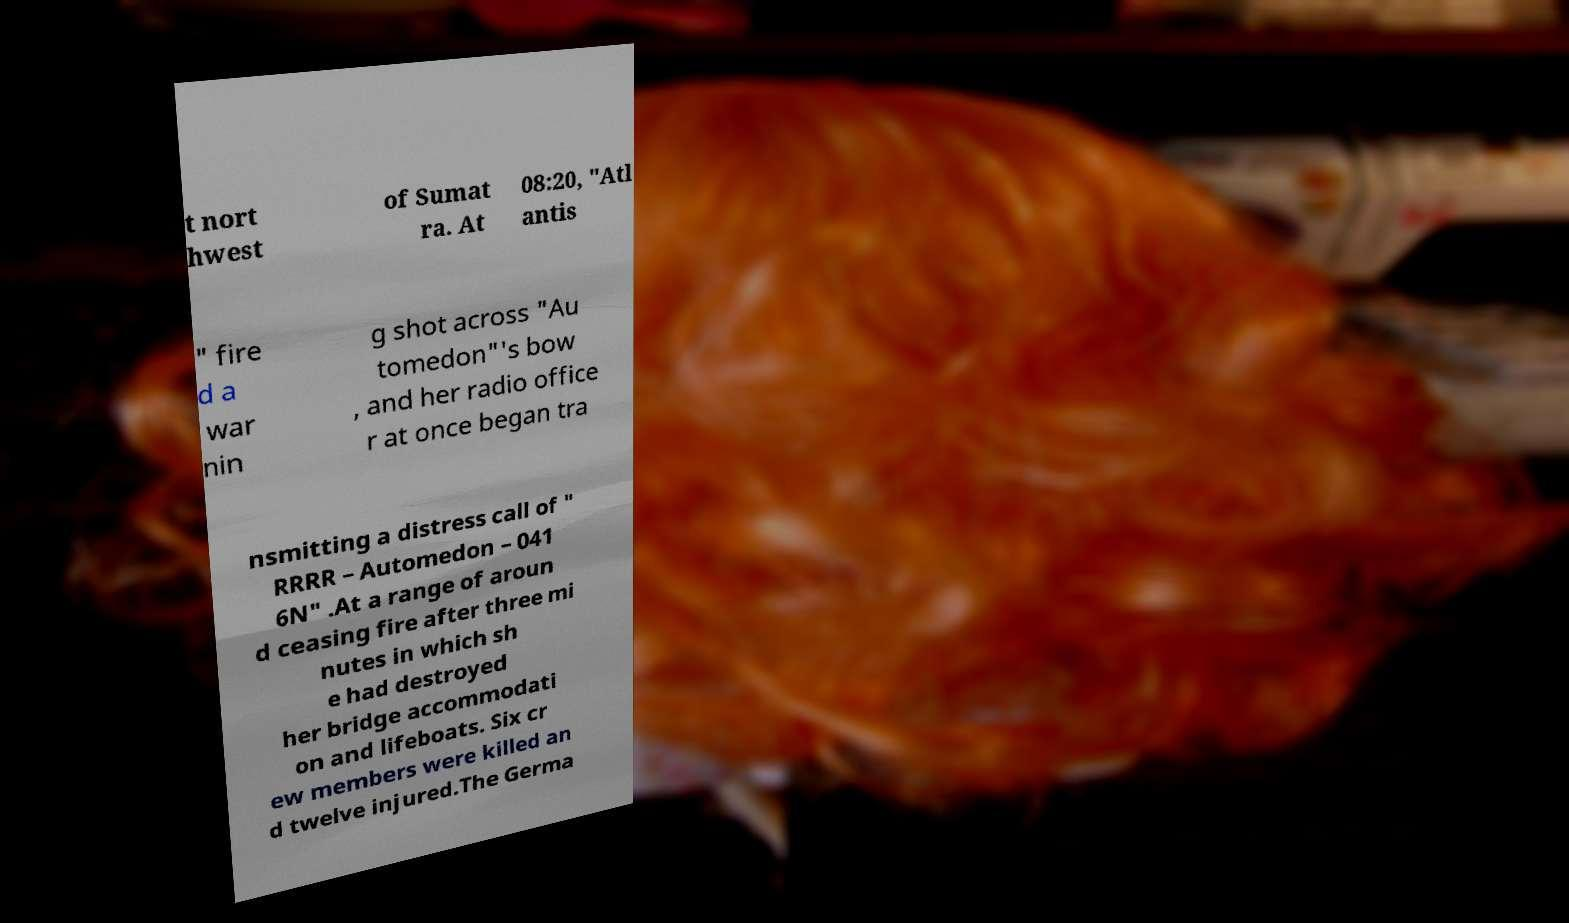Can you read and provide the text displayed in the image?This photo seems to have some interesting text. Can you extract and type it out for me? t nort hwest of Sumat ra. At 08:20, "Atl antis " fire d a war nin g shot across "Au tomedon"'s bow , and her radio office r at once began tra nsmitting a distress call of " RRRR – Automedon – 041 6N" .At a range of aroun d ceasing fire after three mi nutes in which sh e had destroyed her bridge accommodati on and lifeboats. Six cr ew members were killed an d twelve injured.The Germa 